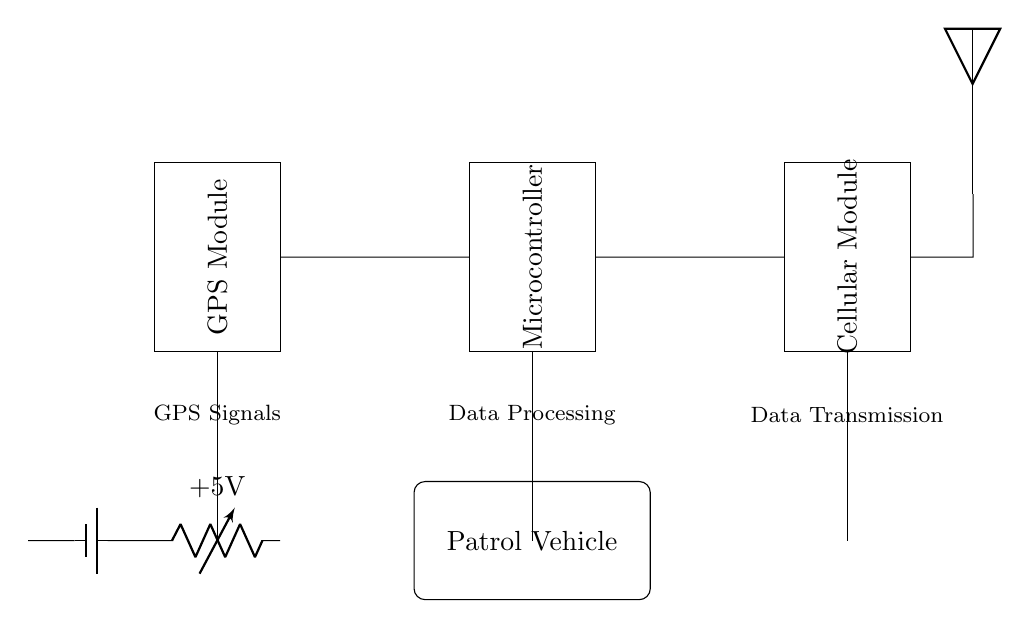What are the main components of the circuit? The main components are the GPS Module, Microcontroller, Cellular Module, and a Power Supply. Each component is represented by a rectangle in the circuit diagram, providing clear identification.
Answer: GPS Module, Microcontroller, Cellular Module, Power Supply What is the power supply voltage? The power supply voltage is indicated as +5V in the circuit. This is found near the battery symbol connected to the circuit.
Answer: 5V What is the role of the Microcontroller? The Microcontroller is responsible for data processing. It is positioned to receive signals from the GPS Module, process the location data, and transmit it through the Cellular Module.
Answer: Data Processing Where does the GPS Module connect? The GPS Module connects to the Microcontroller. There is a direct short connection indicated in the circuit diagram, signifying data transfer between the two components.
Answer: Microcontroller What type of signals does the GPS Module process? The GPS Module processes GPS Signals. This is denoted at the base of the component in the diagram, highlighting its function to determine location.
Answer: GPS Signals How is data transmitted from the circuit? Data is transmitted through the Cellular Module. It is connected to the Microcontroller, which sends the processed information to the Cellular Module for transmission.
Answer: Cellular Module What is represented by the antenna? The antenna represents the output for wireless communication. It is placed at the Cellular Module end and illustrates the capability of the circuit to send location data wirelessly.
Answer: Wireless communication 